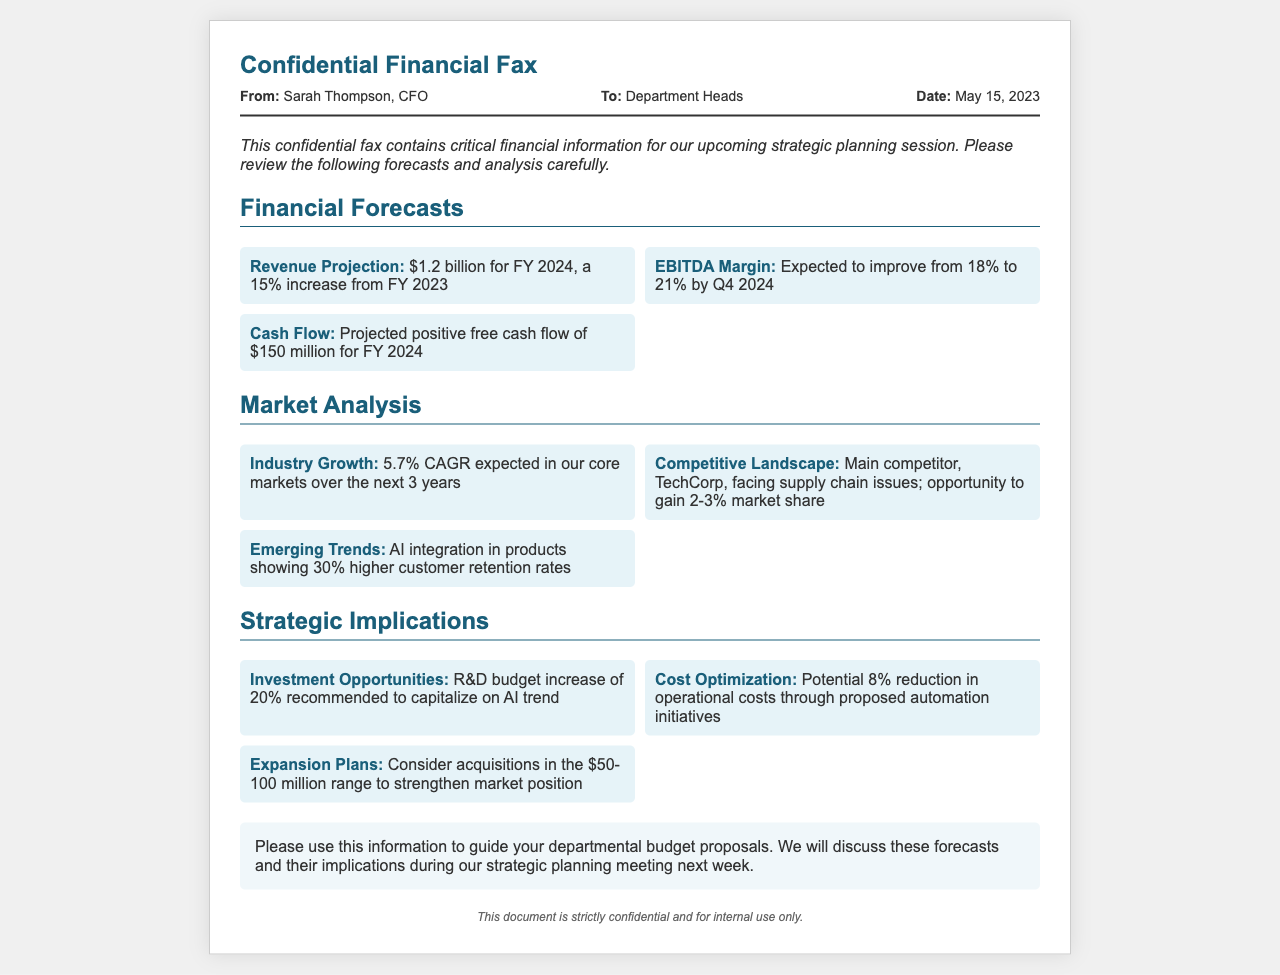What is the revenue projection for FY 2024? The revenue projection is a specific figure mentioned in the financial forecasts section.
Answer: $1.2 billion for FY 2024 What is the expected EBITDA margin by Q4 2024? The document specifies the expected EBITDA margin in the financial forecasts section.
Answer: 21% What is the projected positive free cash flow for FY 2024? This is a specific cash flow figure indicated in the forecasts section.
Answer: $150 million What is the expected industry growth rate over the next 3 years? The industry growth rate is stated in the market analysis section of the document.
Answer: 5.7% CAGR What percentage of market share can be gained from TechCorp's supply chain issues? This is a detail regarding competitive landscape opportunities mentioned in the market analysis.
Answer: 2-3% What is the recommended increase in the R&D budget? This recommendation is provided in the strategic implications section.
Answer: 20% What automation initiatives could lead to a cost reduction? The document references cost optimization through automation initiatives.
Answer: 8% What range is suggested for potential acquisitions? The suggested range for acquisitions is specified in the expansion plans of strategic implications.
Answer: $50-100 million What is the date of the fax? The date is clearly stated in the header of the document.
Answer: May 15, 2023 